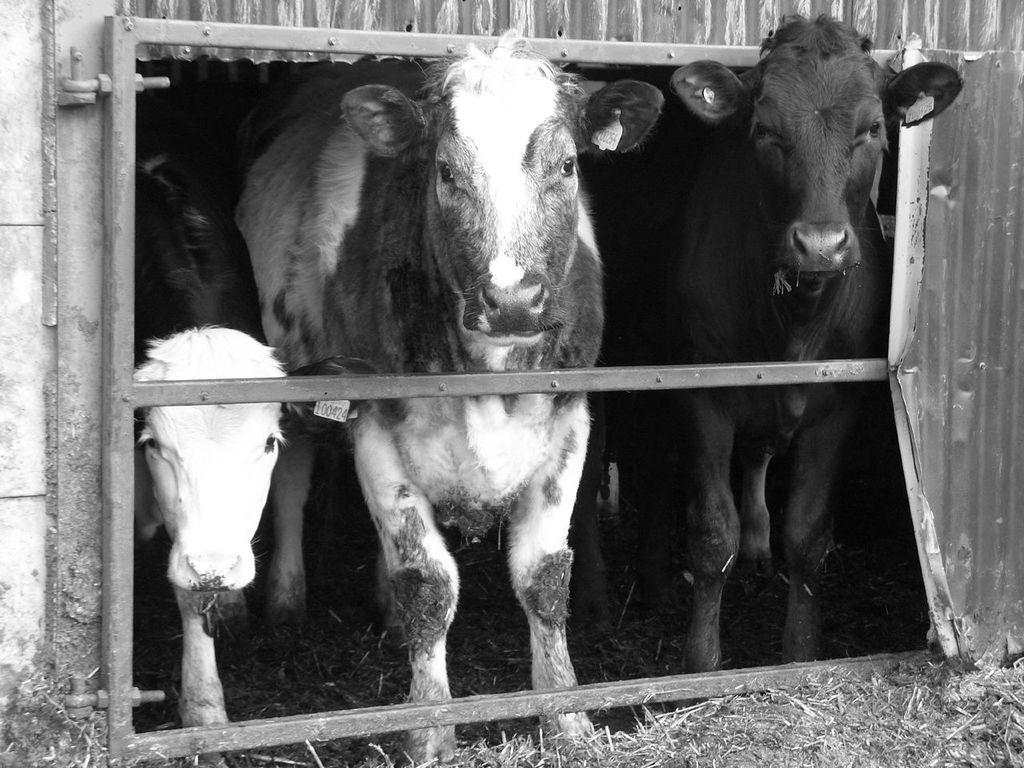What is the color scheme of the image? The image is black and white. What is the main structure in the image? There is a shed in the center of the image. What type of barrier can be seen in the image? There is a fence in the image. What animals are inside the shed? There are three crows inside the shed. How many dolls are visible in the image? There are no dolls present in the image. What type of pollution can be seen in the image? There is no pollution visible in the image. 